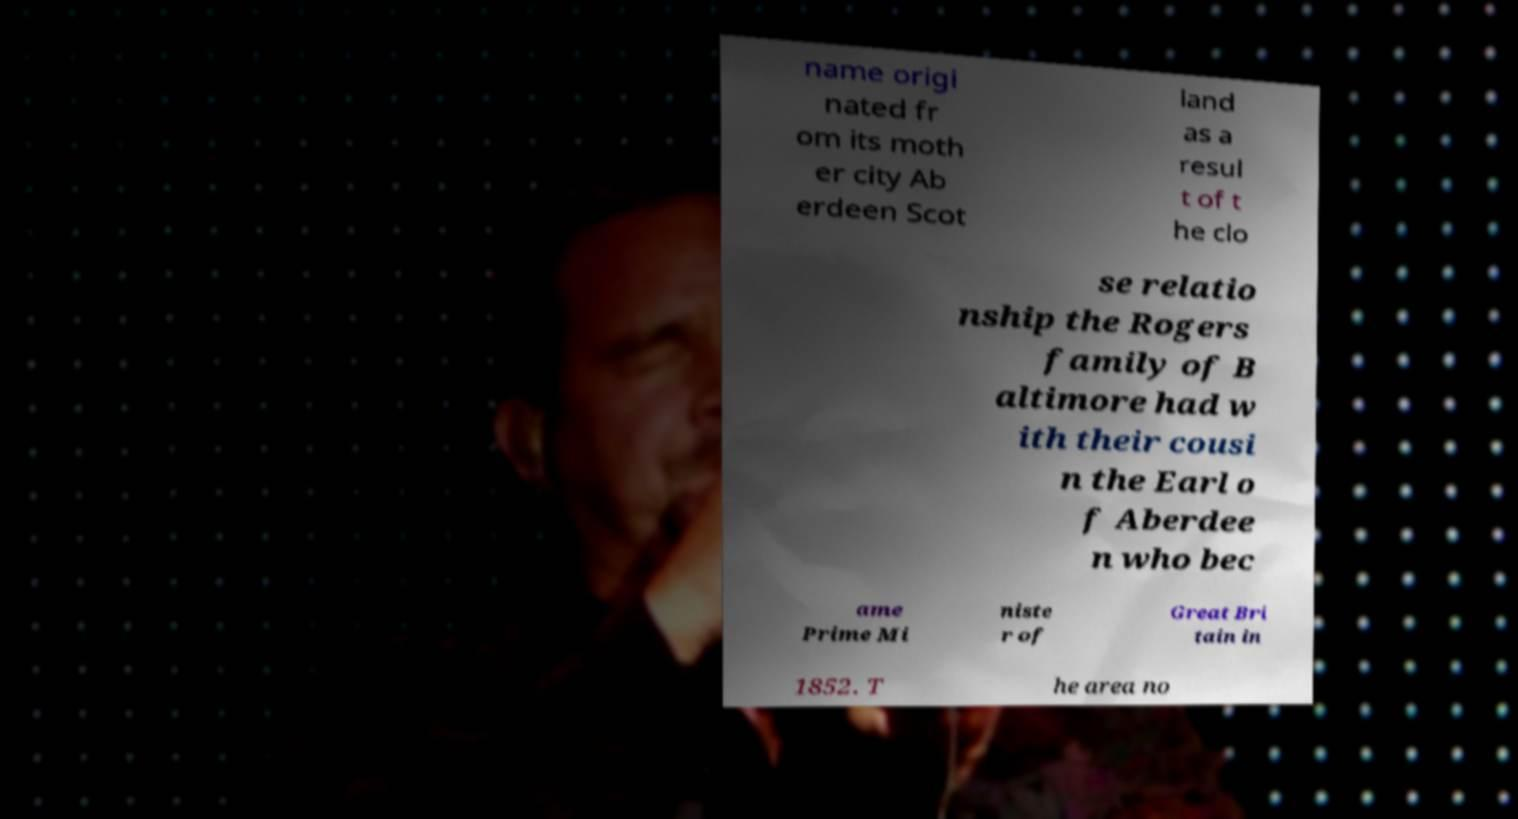Can you accurately transcribe the text from the provided image for me? name origi nated fr om its moth er city Ab erdeen Scot land as a resul t of t he clo se relatio nship the Rogers family of B altimore had w ith their cousi n the Earl o f Aberdee n who bec ame Prime Mi niste r of Great Bri tain in 1852. T he area no 